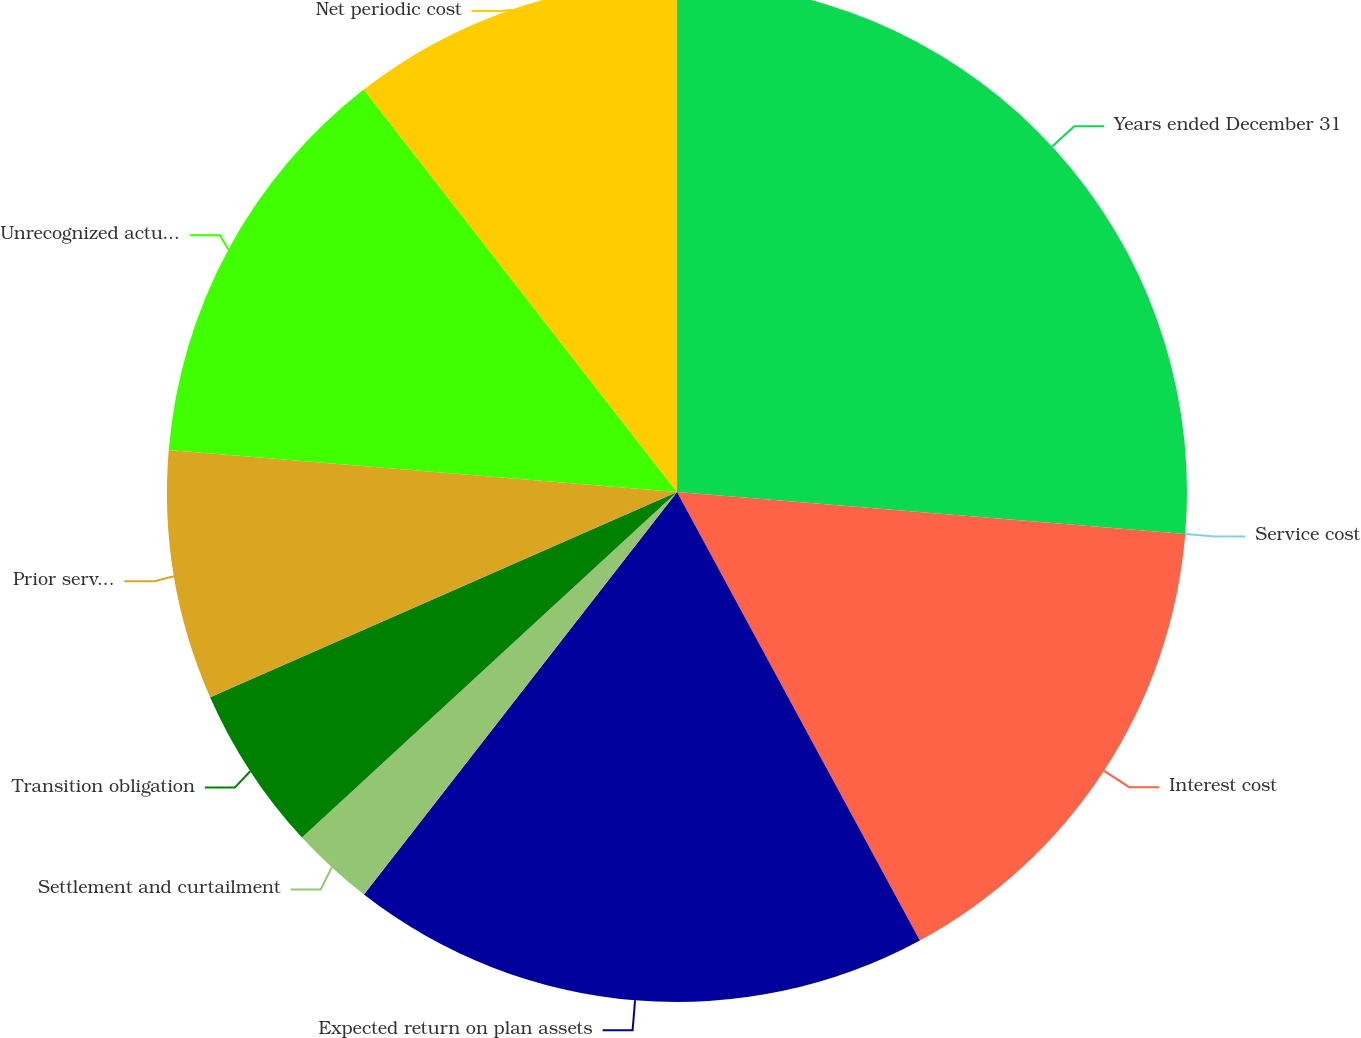<chart> <loc_0><loc_0><loc_500><loc_500><pie_chart><fcel>Years ended December 31<fcel>Service cost<fcel>Interest cost<fcel>Expected return on plan assets<fcel>Settlement and curtailment<fcel>Transition obligation<fcel>Prior service cost (credit)<fcel>Unrecognized actuarial losses<fcel>Net periodic cost<nl><fcel>26.31%<fcel>0.0%<fcel>15.79%<fcel>18.42%<fcel>2.63%<fcel>5.26%<fcel>7.9%<fcel>13.16%<fcel>10.53%<nl></chart> 